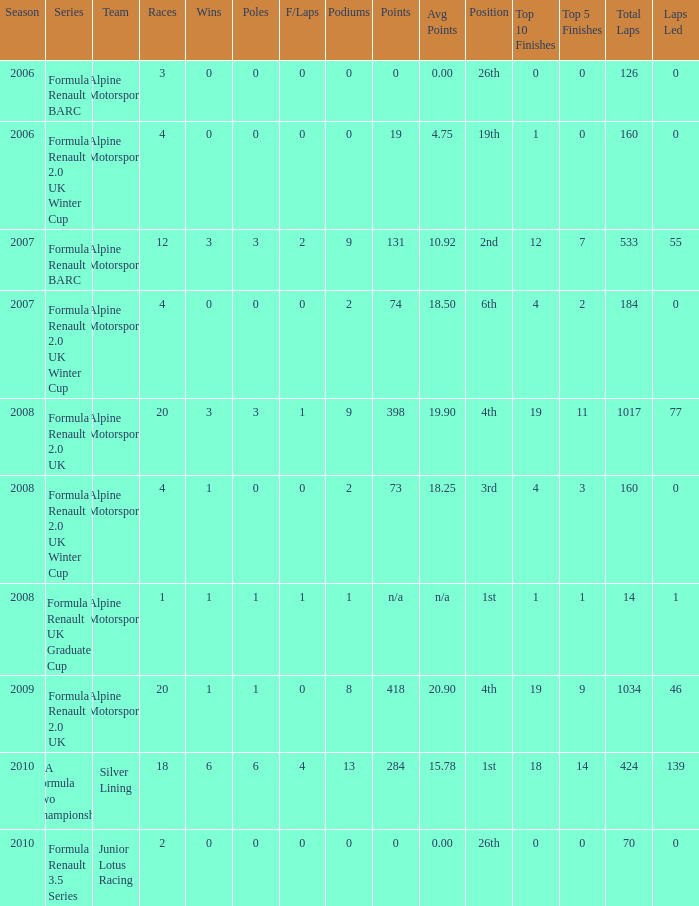What was the first season where the podium count was 9? 2007.0. 